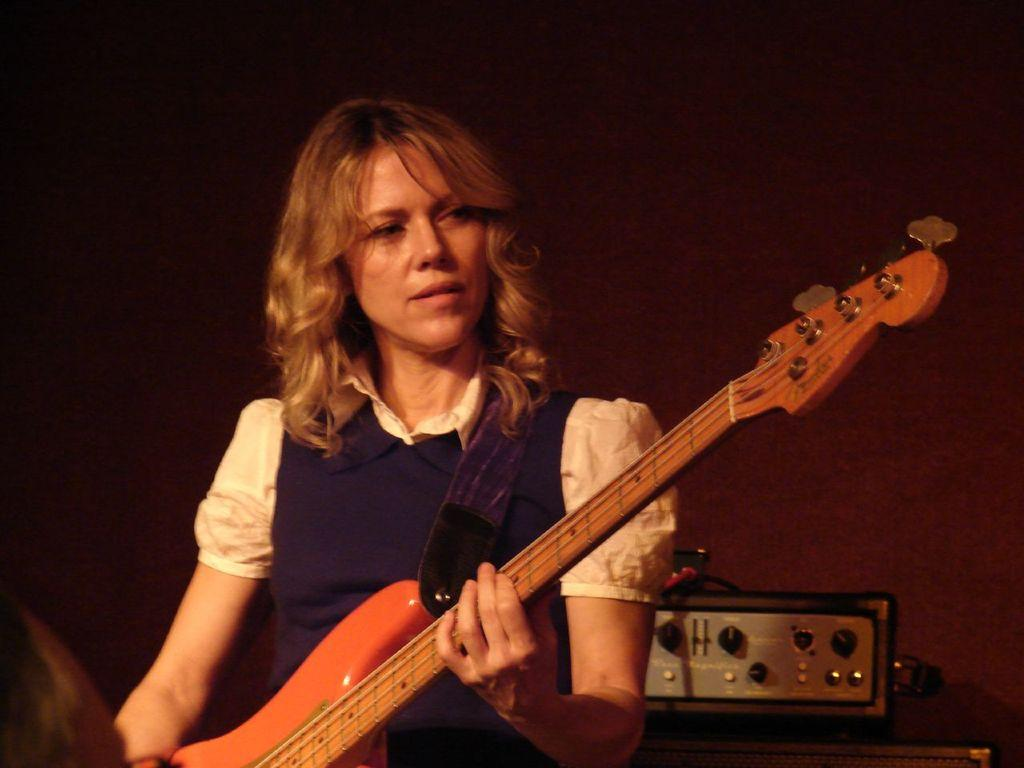What is the woman in the image holding? The woman is holding a guitar. Can you describe the object in the image? Unfortunately, the provided facts do not give any information about the object in the image. What can be seen in the background of the image? There is a wall in the background of the image. What type of account does the woman have with the bank in the image? There is no information about any bank or account in the image. The woman is holding a guitar and there is a wall in the background. Is the woman swimming in the image? No, the woman is not swimming in the image. She is holding a guitar and there is a wall in the background. 